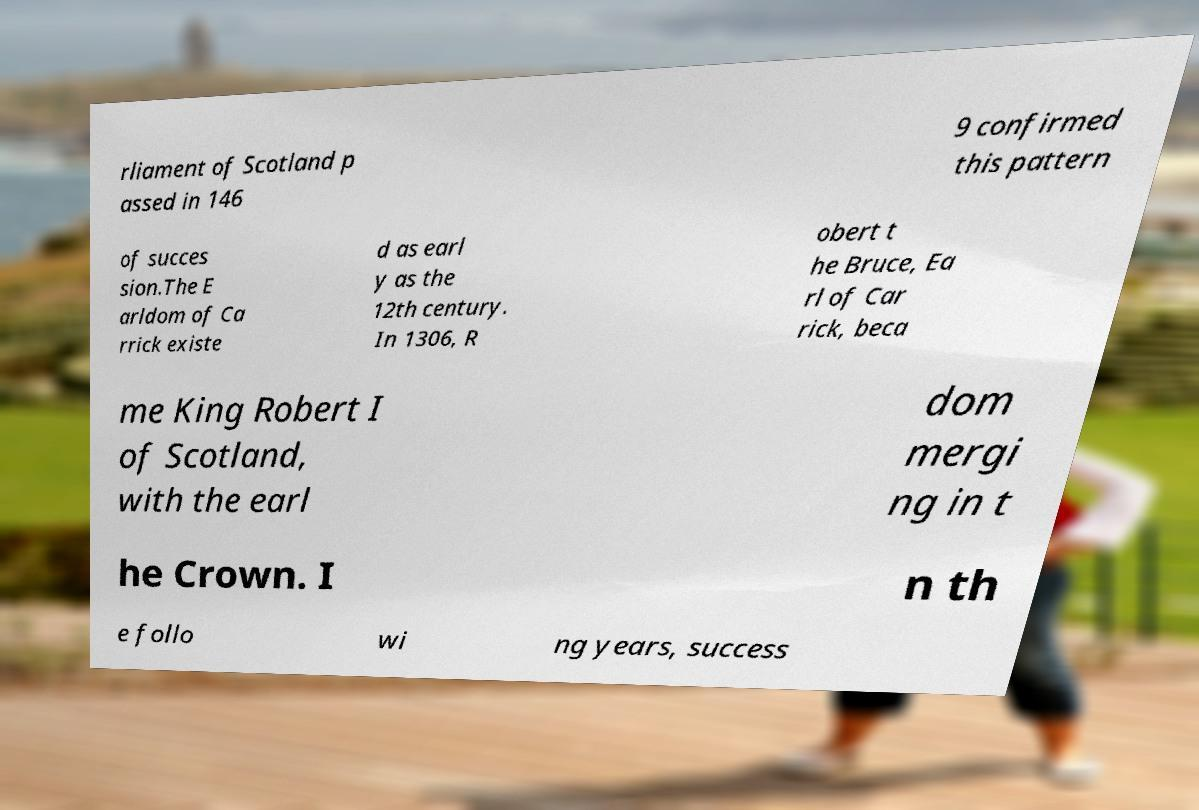I need the written content from this picture converted into text. Can you do that? rliament of Scotland p assed in 146 9 confirmed this pattern of succes sion.The E arldom of Ca rrick existe d as earl y as the 12th century. In 1306, R obert t he Bruce, Ea rl of Car rick, beca me King Robert I of Scotland, with the earl dom mergi ng in t he Crown. I n th e follo wi ng years, success 